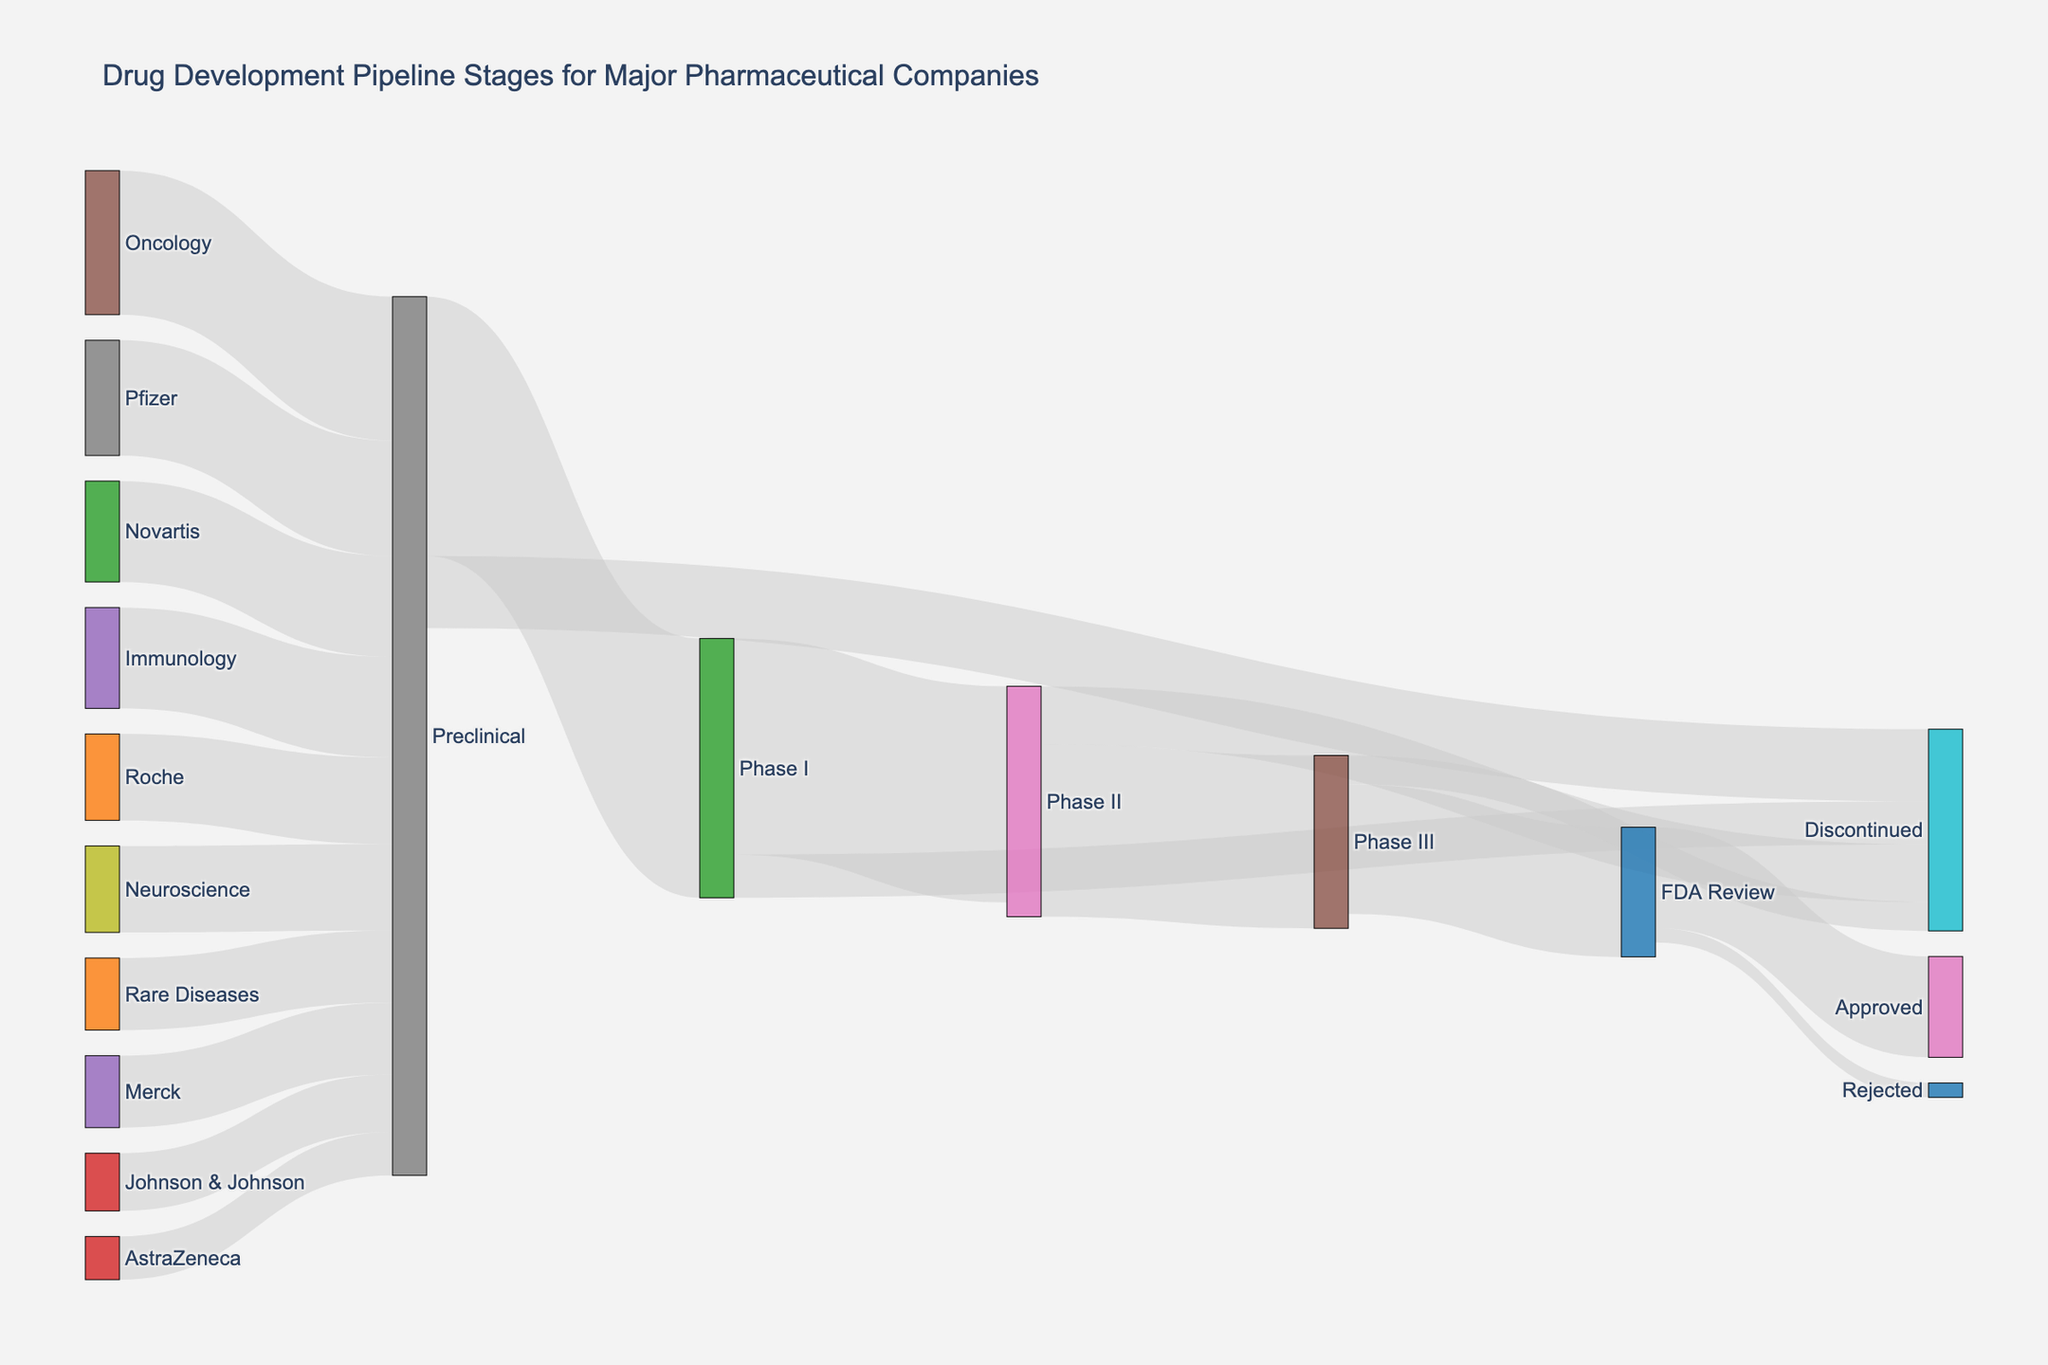How many drugs reached the FDA Review stage? Look at the flow in the Sankey Diagram leading to the "FDA Review" node. There are 9 drugs moving from Phase III to FDA Review.
Answer: 9 Which stage has the most discontinued drugs? Track the thickness of the flows terminating at the "Discontinued" node. The highest value flow into "Discontinued" occurs from the "Preclinical" stage with 5 drugs.
Answer: Preclinical What is the sum of drugs that went from Phase I to either Phase II or got discontinued? The values going from Phase I to Phase II and "Discontinued" are 15 and 3, respectively. The sum is 15 + 3 = 18.
Answer: 18 Which company has the least number of drugs in the Preclinical stage? Compare the flows of companies leading to the "Preclinical" node. AstraZeneca has the least with 3 drugs.
Answer: AstraZeneca What's the difference between the number of drugs initiated in Preclinical and the number that got approved? The total drugs starting in Preclinical is 18+5=23, and those approved are 7. The difference is 23 - 7 = 16.
Answer: 16 How many drugs were rejected by the FDA after review? Check the flow terminating at the "Rejected" node from the "FDA Review" node. Only 1 drug was rejected.
Answer: 1 Which therapeutic area has the highest number of drugs in the Preclinical stage? Compare the sizes of the flows from therapeutic areas to "Preclinical." Oncology has the highest with 10 drugs.
Answer: Oncology What percentage of drugs reached the FDA Review from Phase II? Calculate the ratio of drugs from Phase II to FDA Review to the total in Phase II. From Phase II, 12 are in Phase III, and 9 of those go to FDA Review. Calculate (9/12) * 100%.
Answer: 75% What is the proportion of drugs approved to those that went into FDA Review? Compare the flow from FDA Review to "Approved" (7) and the total reviewed (9). The proportion is 7/9.
Answer: 7/9 Which stage had the most transitions and what were the transitions? The "Preclinical" stage links to Phase I, and Discontinued, having transitions of 18 and 5 respectively.
Answer: Preclinical: Phase I and Discontinued 